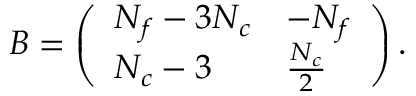Convert formula to latex. <formula><loc_0><loc_0><loc_500><loc_500>B = \left ( \begin{array} { l l } { { N _ { f } - 3 N _ { c } } } & { { - N _ { f } } } \\ { { N _ { c } - 3 } } & { { { \frac { N _ { c } } { 2 } } } } \end{array} \right ) .</formula> 